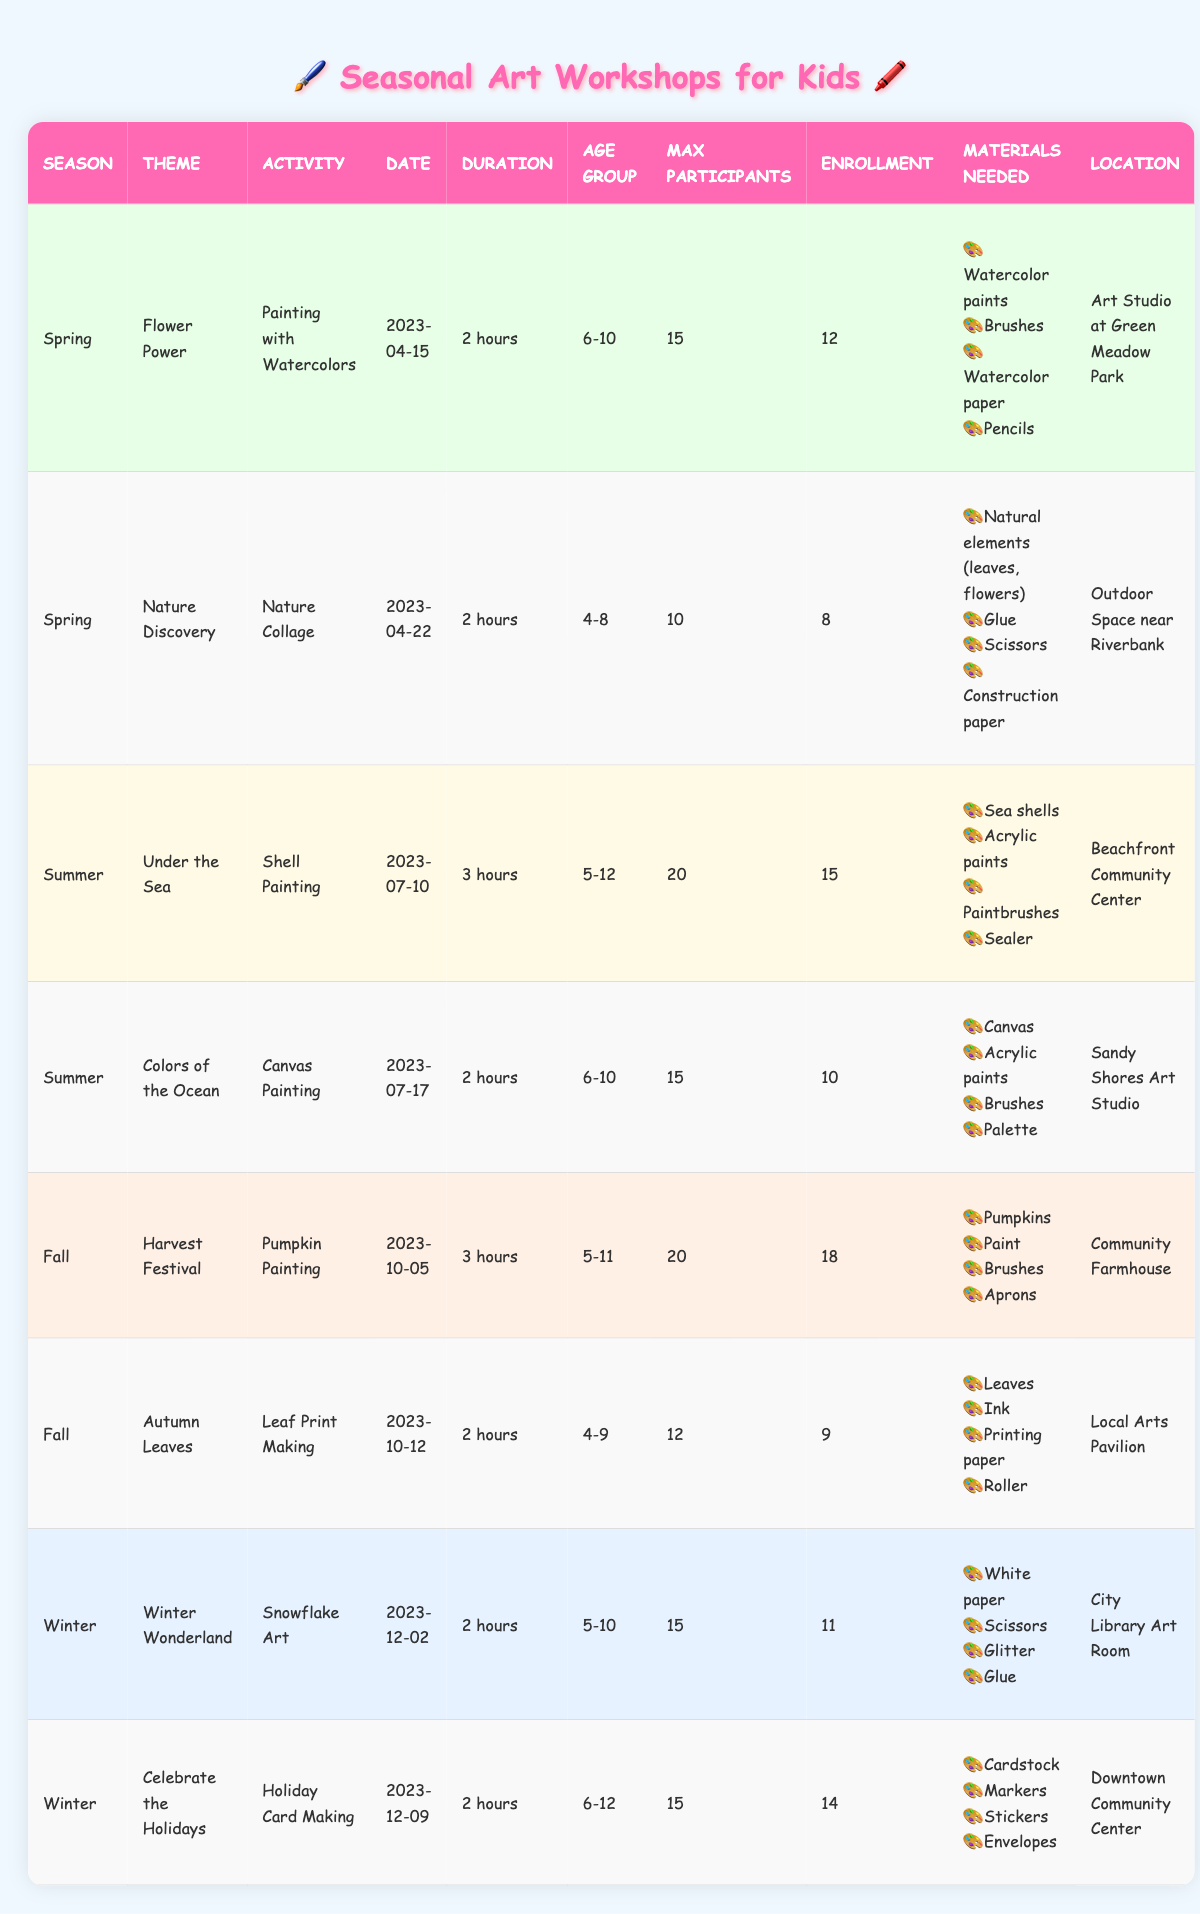What is the theme of the spring workshop on April 15th, 2023? The table shows that the spring workshop on April 15th, 2023, has the theme "Flower Power."
Answer: Flower Power How many participants were enrolled in the "Harvest Festival" workshop? Looking at the table, the "Harvest Festival" workshop has an enrollment of 18 participants.
Answer: 18 What is the maximum number of participants allowed in the "Nature Discovery" workshop? According to the table, the maximum number of participants for the "Nature Discovery" workshop is 10.
Answer: 10 Which winter workshop has a higher enrollment, "Winter Wonderland" or "Celebrate the Holidays"? By comparing the enrollments in the table, "Winter Wonderland" has 11 enrolled participants, while "Celebrate the Holidays" has 14. Therefore, "Celebrate the Holidays" has higher enrollment.
Answer: Celebrate the Holidays For the summer workshops, what is the average maximum number of participants allowed? The summer workshops are "Under the Sea" (20) and "Colors of the Ocean" (15). The average is (20 + 15) / 2 = 17.5.
Answer: 17.5 How many total hours do the fall workshops last? The fall workshops last for 3 hours (Harvest Festival) and 2 hours (Autumn Leaves). Thus, the total hours is 3 + 2 = 5.
Answer: 5 Was the enrollment for the "Leaf Print Making" workshop less than half of its maximum participants? The maximum participants for the "Leaf Print Making" workshop is 12, and its enrollment is 9. Half of 12 is 6, and since 9 is more than 6, the statement is false.
Answer: No What activity had the highest number of allowed participants and what was the theme? The highest allowed participants is 20 for the "Under the Sea" workshop, which has the theme of the same name.
Answer: Under the Sea Which seasonal theme had the most workshops scheduled? From the table, we see that spring has 2 workshops ("Flower Power" and "Nature Discovery"), summer has 2, fall has 2, and winter has 2. Since all seasons have an equal number of workshops, there is no predominant theme.
Answer: None What materials are needed for the "Celebrate the Holidays" workshop? Referring to the table, the materials needed for "Celebrate the Holidays" are cardstock, markers, stickers, and envelopes.
Answer: Cardstock, markers, stickers, envelopes 